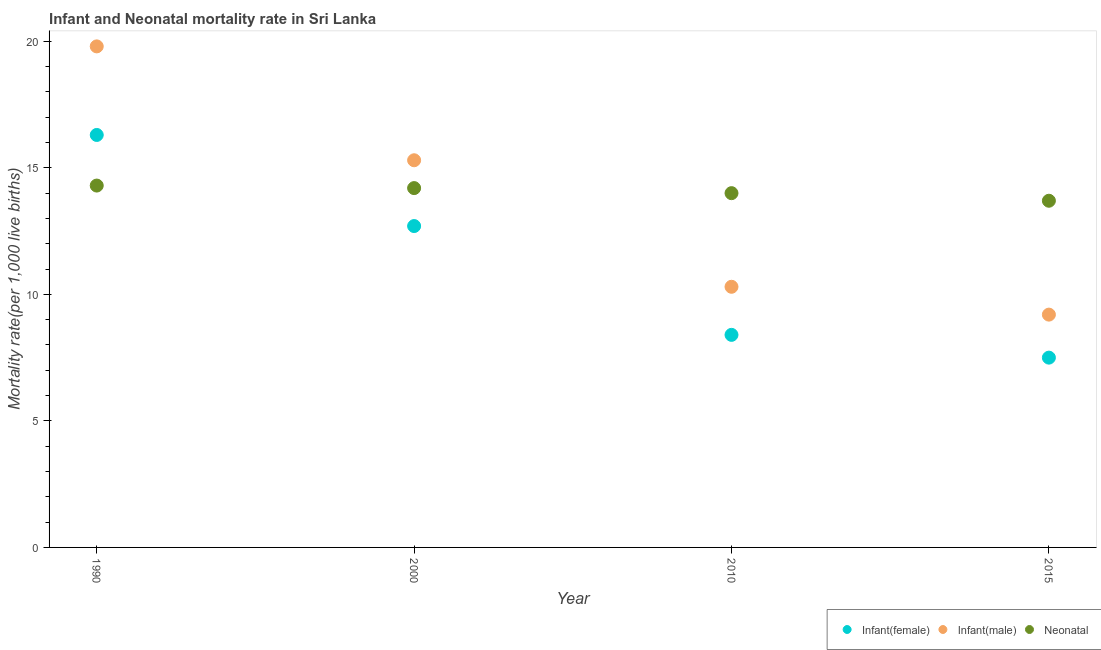Is the number of dotlines equal to the number of legend labels?
Offer a terse response. Yes. Across all years, what is the maximum neonatal mortality rate?
Provide a short and direct response. 14.3. Across all years, what is the minimum infant mortality rate(female)?
Provide a succinct answer. 7.5. In which year was the infant mortality rate(male) minimum?
Offer a very short reply. 2015. What is the total neonatal mortality rate in the graph?
Provide a succinct answer. 56.2. What is the difference between the infant mortality rate(male) in 2000 and that in 2015?
Provide a succinct answer. 6.1. What is the difference between the infant mortality rate(female) in 1990 and the infant mortality rate(male) in 2015?
Give a very brief answer. 7.1. What is the average infant mortality rate(male) per year?
Offer a very short reply. 13.65. In how many years, is the infant mortality rate(female) greater than 2?
Make the answer very short. 4. What is the ratio of the infant mortality rate(male) in 1990 to that in 2000?
Offer a very short reply. 1.29. Is the infant mortality rate(female) in 2010 less than that in 2015?
Give a very brief answer. No. Is the difference between the neonatal mortality rate in 1990 and 2015 greater than the difference between the infant mortality rate(female) in 1990 and 2015?
Your answer should be compact. No. What is the difference between the highest and the second highest neonatal mortality rate?
Your response must be concise. 0.1. What is the difference between the highest and the lowest infant mortality rate(male)?
Give a very brief answer. 10.6. Is it the case that in every year, the sum of the infant mortality rate(female) and infant mortality rate(male) is greater than the neonatal mortality rate?
Provide a succinct answer. Yes. Does the neonatal mortality rate monotonically increase over the years?
Your response must be concise. No. Is the neonatal mortality rate strictly greater than the infant mortality rate(male) over the years?
Provide a short and direct response. No. Is the neonatal mortality rate strictly less than the infant mortality rate(female) over the years?
Provide a short and direct response. No. How many dotlines are there?
Provide a short and direct response. 3. Where does the legend appear in the graph?
Your response must be concise. Bottom right. What is the title of the graph?
Offer a terse response. Infant and Neonatal mortality rate in Sri Lanka. Does "Gaseous fuel" appear as one of the legend labels in the graph?
Your response must be concise. No. What is the label or title of the X-axis?
Keep it short and to the point. Year. What is the label or title of the Y-axis?
Offer a very short reply. Mortality rate(per 1,0 live births). What is the Mortality rate(per 1,000 live births) of Infant(male) in 1990?
Offer a very short reply. 19.8. What is the Mortality rate(per 1,000 live births) in Infant(male) in 2000?
Your response must be concise. 15.3. What is the Mortality rate(per 1,000 live births) of Neonatal  in 2000?
Your answer should be very brief. 14.2. What is the Mortality rate(per 1,000 live births) of Infant(male) in 2010?
Ensure brevity in your answer.  10.3. What is the Mortality rate(per 1,000 live births) of Infant(male) in 2015?
Offer a terse response. 9.2. What is the Mortality rate(per 1,000 live births) of Neonatal  in 2015?
Offer a very short reply. 13.7. Across all years, what is the maximum Mortality rate(per 1,000 live births) in Infant(male)?
Offer a terse response. 19.8. Across all years, what is the minimum Mortality rate(per 1,000 live births) in Neonatal ?
Your response must be concise. 13.7. What is the total Mortality rate(per 1,000 live births) in Infant(female) in the graph?
Provide a succinct answer. 44.9. What is the total Mortality rate(per 1,000 live births) of Infant(male) in the graph?
Your answer should be compact. 54.6. What is the total Mortality rate(per 1,000 live births) of Neonatal  in the graph?
Offer a very short reply. 56.2. What is the difference between the Mortality rate(per 1,000 live births) in Infant(female) in 1990 and that in 2010?
Your answer should be very brief. 7.9. What is the difference between the Mortality rate(per 1,000 live births) of Infant(male) in 1990 and that in 2010?
Your answer should be very brief. 9.5. What is the difference between the Mortality rate(per 1,000 live births) in Neonatal  in 1990 and that in 2015?
Your answer should be very brief. 0.6. What is the difference between the Mortality rate(per 1,000 live births) of Infant(female) in 2000 and that in 2010?
Make the answer very short. 4.3. What is the difference between the Mortality rate(per 1,000 live births) in Infant(female) in 2000 and that in 2015?
Make the answer very short. 5.2. What is the difference between the Mortality rate(per 1,000 live births) of Infant(male) in 2000 and that in 2015?
Ensure brevity in your answer.  6.1. What is the difference between the Mortality rate(per 1,000 live births) of Infant(male) in 2010 and that in 2015?
Keep it short and to the point. 1.1. What is the difference between the Mortality rate(per 1,000 live births) in Infant(female) in 1990 and the Mortality rate(per 1,000 live births) in Infant(male) in 2000?
Offer a very short reply. 1. What is the difference between the Mortality rate(per 1,000 live births) in Infant(female) in 1990 and the Mortality rate(per 1,000 live births) in Neonatal  in 2000?
Offer a terse response. 2.1. What is the difference between the Mortality rate(per 1,000 live births) of Infant(female) in 1990 and the Mortality rate(per 1,000 live births) of Neonatal  in 2010?
Give a very brief answer. 2.3. What is the difference between the Mortality rate(per 1,000 live births) in Infant(male) in 1990 and the Mortality rate(per 1,000 live births) in Neonatal  in 2010?
Give a very brief answer. 5.8. What is the difference between the Mortality rate(per 1,000 live births) of Infant(female) in 1990 and the Mortality rate(per 1,000 live births) of Infant(male) in 2015?
Offer a terse response. 7.1. What is the difference between the Mortality rate(per 1,000 live births) in Infant(female) in 1990 and the Mortality rate(per 1,000 live births) in Neonatal  in 2015?
Offer a very short reply. 2.6. What is the difference between the Mortality rate(per 1,000 live births) of Infant(male) in 1990 and the Mortality rate(per 1,000 live births) of Neonatal  in 2015?
Give a very brief answer. 6.1. What is the difference between the Mortality rate(per 1,000 live births) of Infant(female) in 2000 and the Mortality rate(per 1,000 live births) of Infant(male) in 2015?
Your response must be concise. 3.5. What is the difference between the Mortality rate(per 1,000 live births) of Infant(female) in 2000 and the Mortality rate(per 1,000 live births) of Neonatal  in 2015?
Offer a very short reply. -1. What is the difference between the Mortality rate(per 1,000 live births) of Infant(female) in 2010 and the Mortality rate(per 1,000 live births) of Infant(male) in 2015?
Your answer should be compact. -0.8. What is the difference between the Mortality rate(per 1,000 live births) in Infant(female) in 2010 and the Mortality rate(per 1,000 live births) in Neonatal  in 2015?
Offer a very short reply. -5.3. What is the difference between the Mortality rate(per 1,000 live births) in Infant(male) in 2010 and the Mortality rate(per 1,000 live births) in Neonatal  in 2015?
Give a very brief answer. -3.4. What is the average Mortality rate(per 1,000 live births) in Infant(female) per year?
Your response must be concise. 11.22. What is the average Mortality rate(per 1,000 live births) of Infant(male) per year?
Provide a succinct answer. 13.65. What is the average Mortality rate(per 1,000 live births) of Neonatal  per year?
Your answer should be compact. 14.05. In the year 1990, what is the difference between the Mortality rate(per 1,000 live births) in Infant(male) and Mortality rate(per 1,000 live births) in Neonatal ?
Your answer should be compact. 5.5. In the year 2000, what is the difference between the Mortality rate(per 1,000 live births) of Infant(female) and Mortality rate(per 1,000 live births) of Neonatal ?
Ensure brevity in your answer.  -1.5. In the year 2010, what is the difference between the Mortality rate(per 1,000 live births) in Infant(female) and Mortality rate(per 1,000 live births) in Infant(male)?
Provide a short and direct response. -1.9. In the year 2010, what is the difference between the Mortality rate(per 1,000 live births) of Infant(female) and Mortality rate(per 1,000 live births) of Neonatal ?
Ensure brevity in your answer.  -5.6. In the year 2010, what is the difference between the Mortality rate(per 1,000 live births) of Infant(male) and Mortality rate(per 1,000 live births) of Neonatal ?
Provide a succinct answer. -3.7. In the year 2015, what is the difference between the Mortality rate(per 1,000 live births) of Infant(female) and Mortality rate(per 1,000 live births) of Neonatal ?
Your answer should be compact. -6.2. In the year 2015, what is the difference between the Mortality rate(per 1,000 live births) of Infant(male) and Mortality rate(per 1,000 live births) of Neonatal ?
Your answer should be very brief. -4.5. What is the ratio of the Mortality rate(per 1,000 live births) of Infant(female) in 1990 to that in 2000?
Provide a short and direct response. 1.28. What is the ratio of the Mortality rate(per 1,000 live births) in Infant(male) in 1990 to that in 2000?
Provide a succinct answer. 1.29. What is the ratio of the Mortality rate(per 1,000 live births) in Neonatal  in 1990 to that in 2000?
Provide a succinct answer. 1.01. What is the ratio of the Mortality rate(per 1,000 live births) of Infant(female) in 1990 to that in 2010?
Your response must be concise. 1.94. What is the ratio of the Mortality rate(per 1,000 live births) of Infant(male) in 1990 to that in 2010?
Your answer should be very brief. 1.92. What is the ratio of the Mortality rate(per 1,000 live births) in Neonatal  in 1990 to that in 2010?
Your response must be concise. 1.02. What is the ratio of the Mortality rate(per 1,000 live births) in Infant(female) in 1990 to that in 2015?
Your answer should be very brief. 2.17. What is the ratio of the Mortality rate(per 1,000 live births) of Infant(male) in 1990 to that in 2015?
Your answer should be very brief. 2.15. What is the ratio of the Mortality rate(per 1,000 live births) of Neonatal  in 1990 to that in 2015?
Offer a very short reply. 1.04. What is the ratio of the Mortality rate(per 1,000 live births) of Infant(female) in 2000 to that in 2010?
Make the answer very short. 1.51. What is the ratio of the Mortality rate(per 1,000 live births) in Infant(male) in 2000 to that in 2010?
Offer a terse response. 1.49. What is the ratio of the Mortality rate(per 1,000 live births) of Neonatal  in 2000 to that in 2010?
Your answer should be compact. 1.01. What is the ratio of the Mortality rate(per 1,000 live births) in Infant(female) in 2000 to that in 2015?
Your response must be concise. 1.69. What is the ratio of the Mortality rate(per 1,000 live births) of Infant(male) in 2000 to that in 2015?
Your response must be concise. 1.66. What is the ratio of the Mortality rate(per 1,000 live births) of Neonatal  in 2000 to that in 2015?
Your answer should be very brief. 1.04. What is the ratio of the Mortality rate(per 1,000 live births) of Infant(female) in 2010 to that in 2015?
Your answer should be very brief. 1.12. What is the ratio of the Mortality rate(per 1,000 live births) of Infant(male) in 2010 to that in 2015?
Provide a succinct answer. 1.12. What is the ratio of the Mortality rate(per 1,000 live births) of Neonatal  in 2010 to that in 2015?
Ensure brevity in your answer.  1.02. What is the difference between the highest and the second highest Mortality rate(per 1,000 live births) of Infant(female)?
Your answer should be compact. 3.6. What is the difference between the highest and the lowest Mortality rate(per 1,000 live births) of Infant(male)?
Provide a succinct answer. 10.6. What is the difference between the highest and the lowest Mortality rate(per 1,000 live births) of Neonatal ?
Offer a very short reply. 0.6. 